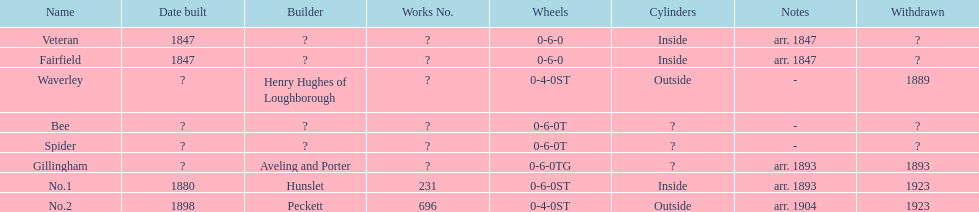What name comes next fairfield? Waverley. 